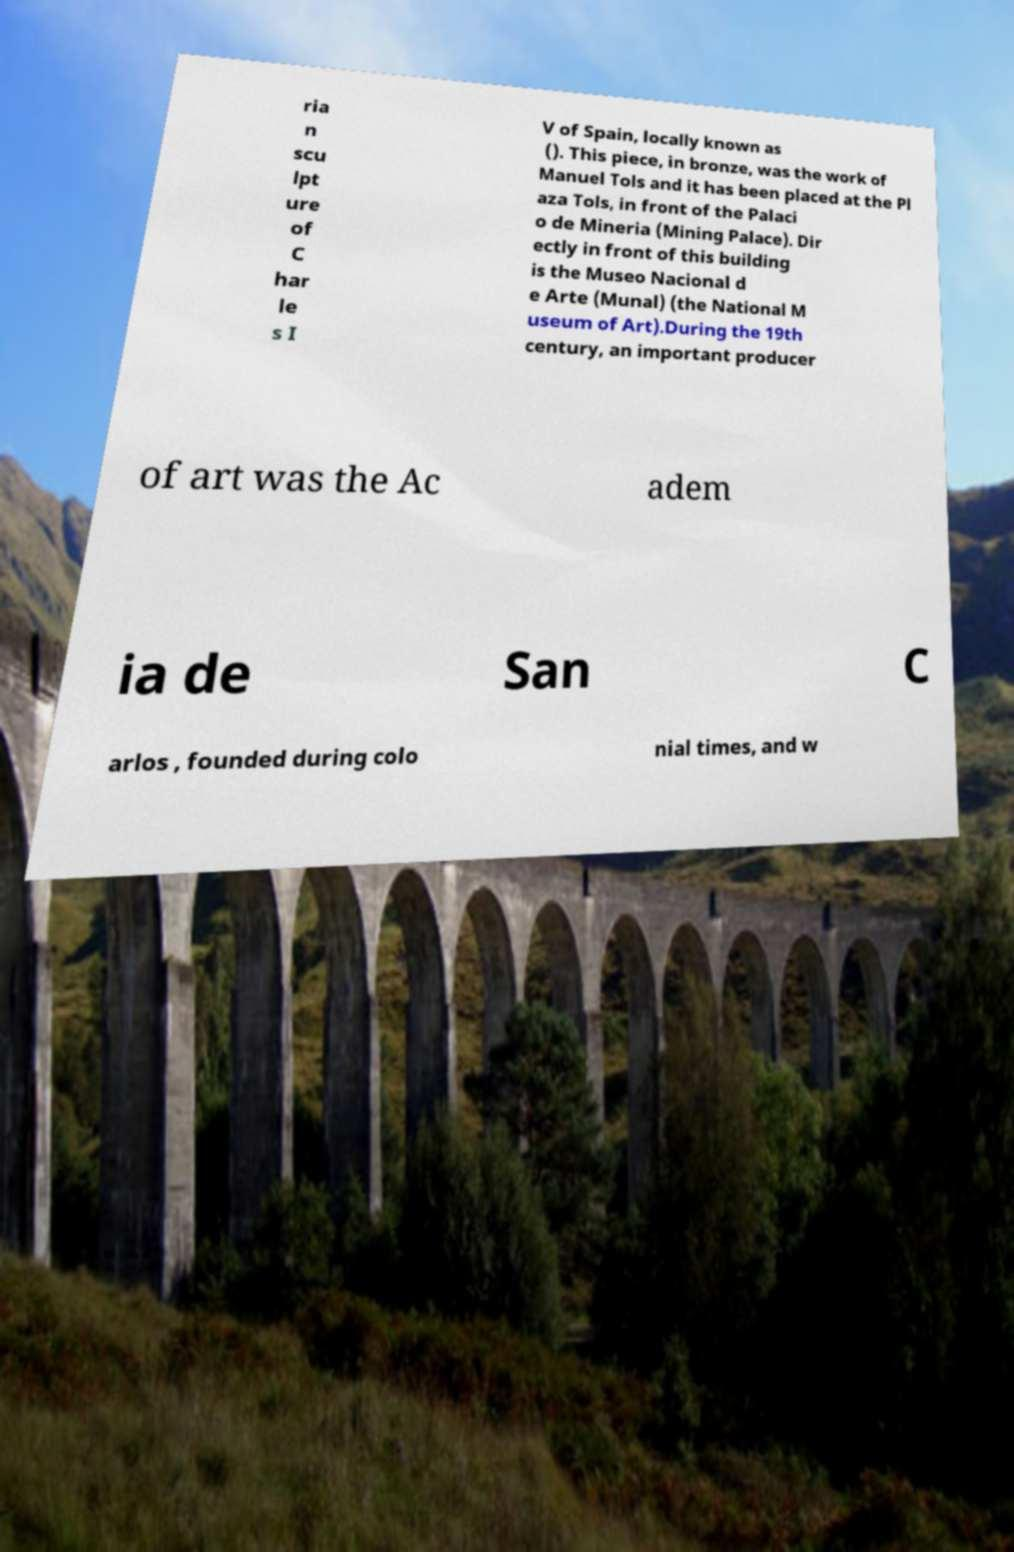Can you accurately transcribe the text from the provided image for me? ria n scu lpt ure of C har le s I V of Spain, locally known as (). This piece, in bronze, was the work of Manuel Tols and it has been placed at the Pl aza Tols, in front of the Palaci o de Mineria (Mining Palace). Dir ectly in front of this building is the Museo Nacional d e Arte (Munal) (the National M useum of Art).During the 19th century, an important producer of art was the Ac adem ia de San C arlos , founded during colo nial times, and w 